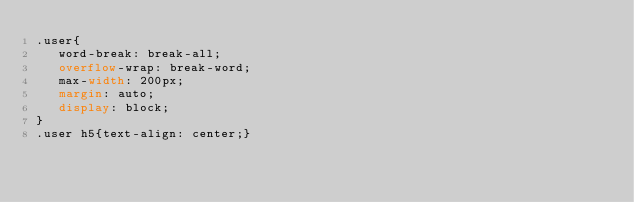<code> <loc_0><loc_0><loc_500><loc_500><_CSS_>.user{
   word-break: break-all;
   overflow-wrap: break-word;
   max-width: 200px;
   margin: auto;
   display: block;
}
.user h5{text-align: center;}</code> 